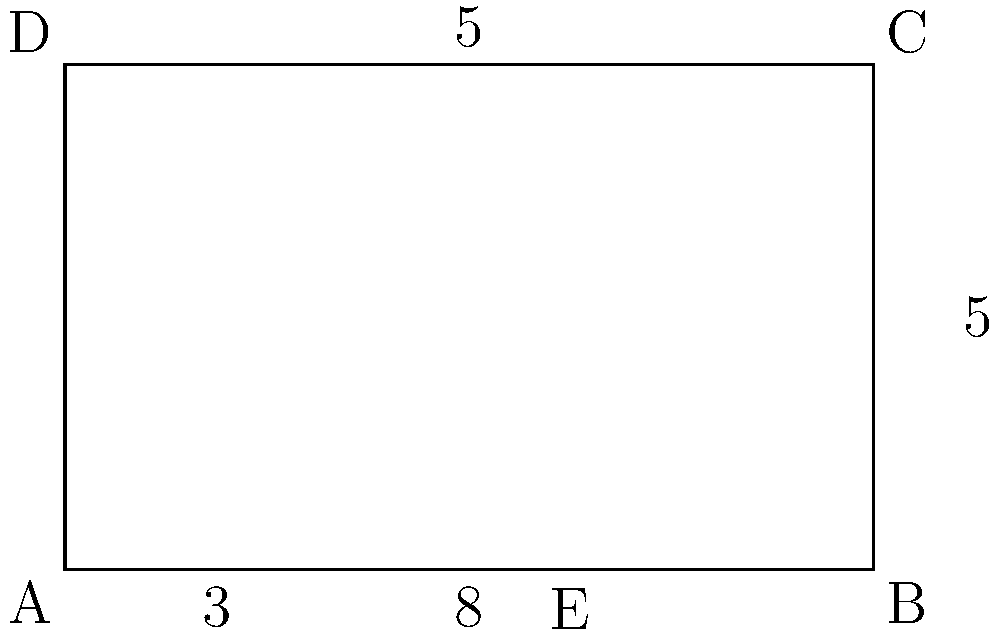In a golden rectangle used for cinematic framing, the ratio of the longer side to the shorter side is approximately 1.618. If the width of the frame is 8 units and the height is 5 units, what is the length of the shorter segment created when the golden ratio divides the width? To solve this problem, let's follow these steps:

1) The golden ratio is approximately 1.618, which means:
   $\frac{\text{longer side}}{\text{shorter side}} \approx 1.618$

2) In this case, the longer side (width) is 8 units and the shorter side (height) is 5 units.

3) We need to find the point E that divides AB in the golden ratio. Let's call the length of AE as x.

4) According to the golden ratio property:
   $\frac{AB}{AE} = \frac{AE}{EB}$

5) We can write this as an equation:
   $\frac{8}{x} = \frac{x}{8-x}$

6) Cross multiply:
   $8(8-x) = x^2$

7) Expand:
   $64 - 8x = x^2$

8) Rearrange:
   $x^2 + 8x - 64 = 0$

9) This is a quadratic equation. We can solve it using the quadratic formula:
   $x = \frac{-b \pm \sqrt{b^2 - 4ac}}{2a}$

   Where $a=1$, $b=8$, and $c=-64$

10) Plugging in these values:
    $x = \frac{-8 \pm \sqrt{64 + 256}}{2} = \frac{-8 \pm \sqrt{320}}{2}$

11) Simplify:
    $x = \frac{-8 \pm 4\sqrt{20}}{2} = -4 \pm 2\sqrt{20}$

12) We're only interested in the positive solution:
    $x = -4 + 2\sqrt{20} \approx 4.944$

Therefore, the length of the shorter segment (AE) is approximately 4.944 units.
Answer: $4.944$ units 